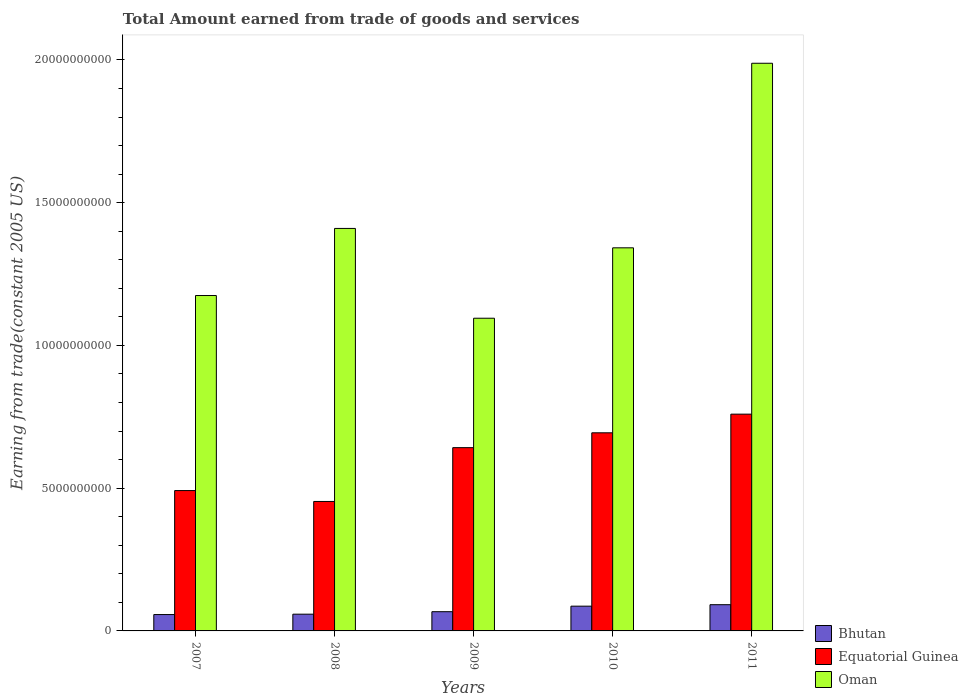Are the number of bars per tick equal to the number of legend labels?
Your answer should be very brief. Yes. How many bars are there on the 2nd tick from the right?
Offer a very short reply. 3. What is the label of the 1st group of bars from the left?
Your answer should be very brief. 2007. In how many cases, is the number of bars for a given year not equal to the number of legend labels?
Make the answer very short. 0. What is the total amount earned by trading goods and services in Bhutan in 2008?
Ensure brevity in your answer.  5.86e+08. Across all years, what is the maximum total amount earned by trading goods and services in Bhutan?
Offer a terse response. 9.19e+08. Across all years, what is the minimum total amount earned by trading goods and services in Bhutan?
Provide a succinct answer. 5.73e+08. In which year was the total amount earned by trading goods and services in Oman maximum?
Offer a terse response. 2011. What is the total total amount earned by trading goods and services in Equatorial Guinea in the graph?
Make the answer very short. 3.04e+1. What is the difference between the total amount earned by trading goods and services in Equatorial Guinea in 2009 and that in 2011?
Offer a terse response. -1.17e+09. What is the difference between the total amount earned by trading goods and services in Equatorial Guinea in 2008 and the total amount earned by trading goods and services in Bhutan in 2009?
Keep it short and to the point. 3.86e+09. What is the average total amount earned by trading goods and services in Oman per year?
Offer a terse response. 1.40e+1. In the year 2011, what is the difference between the total amount earned by trading goods and services in Bhutan and total amount earned by trading goods and services in Oman?
Your response must be concise. -1.90e+1. What is the ratio of the total amount earned by trading goods and services in Bhutan in 2007 to that in 2008?
Give a very brief answer. 0.98. Is the total amount earned by trading goods and services in Oman in 2007 less than that in 2009?
Your answer should be compact. No. Is the difference between the total amount earned by trading goods and services in Bhutan in 2008 and 2010 greater than the difference between the total amount earned by trading goods and services in Oman in 2008 and 2010?
Offer a terse response. No. What is the difference between the highest and the second highest total amount earned by trading goods and services in Equatorial Guinea?
Provide a short and direct response. 6.54e+08. What is the difference between the highest and the lowest total amount earned by trading goods and services in Oman?
Your response must be concise. 8.93e+09. What does the 1st bar from the left in 2008 represents?
Give a very brief answer. Bhutan. What does the 3rd bar from the right in 2010 represents?
Offer a terse response. Bhutan. Is it the case that in every year, the sum of the total amount earned by trading goods and services in Bhutan and total amount earned by trading goods and services in Equatorial Guinea is greater than the total amount earned by trading goods and services in Oman?
Provide a succinct answer. No. What is the difference between two consecutive major ticks on the Y-axis?
Your answer should be compact. 5.00e+09. Are the values on the major ticks of Y-axis written in scientific E-notation?
Offer a very short reply. No. Does the graph contain grids?
Make the answer very short. No. What is the title of the graph?
Ensure brevity in your answer.  Total Amount earned from trade of goods and services. What is the label or title of the X-axis?
Offer a terse response. Years. What is the label or title of the Y-axis?
Offer a very short reply. Earning from trade(constant 2005 US). What is the Earning from trade(constant 2005 US) of Bhutan in 2007?
Keep it short and to the point. 5.73e+08. What is the Earning from trade(constant 2005 US) of Equatorial Guinea in 2007?
Ensure brevity in your answer.  4.92e+09. What is the Earning from trade(constant 2005 US) of Oman in 2007?
Make the answer very short. 1.17e+1. What is the Earning from trade(constant 2005 US) of Bhutan in 2008?
Give a very brief answer. 5.86e+08. What is the Earning from trade(constant 2005 US) in Equatorial Guinea in 2008?
Offer a terse response. 4.53e+09. What is the Earning from trade(constant 2005 US) of Oman in 2008?
Make the answer very short. 1.41e+1. What is the Earning from trade(constant 2005 US) in Bhutan in 2009?
Ensure brevity in your answer.  6.73e+08. What is the Earning from trade(constant 2005 US) of Equatorial Guinea in 2009?
Provide a succinct answer. 6.42e+09. What is the Earning from trade(constant 2005 US) in Oman in 2009?
Keep it short and to the point. 1.10e+1. What is the Earning from trade(constant 2005 US) in Bhutan in 2010?
Provide a short and direct response. 8.67e+08. What is the Earning from trade(constant 2005 US) of Equatorial Guinea in 2010?
Provide a short and direct response. 6.94e+09. What is the Earning from trade(constant 2005 US) of Oman in 2010?
Give a very brief answer. 1.34e+1. What is the Earning from trade(constant 2005 US) in Bhutan in 2011?
Your response must be concise. 9.19e+08. What is the Earning from trade(constant 2005 US) in Equatorial Guinea in 2011?
Your response must be concise. 7.59e+09. What is the Earning from trade(constant 2005 US) in Oman in 2011?
Your answer should be very brief. 1.99e+1. Across all years, what is the maximum Earning from trade(constant 2005 US) of Bhutan?
Provide a short and direct response. 9.19e+08. Across all years, what is the maximum Earning from trade(constant 2005 US) in Equatorial Guinea?
Your response must be concise. 7.59e+09. Across all years, what is the maximum Earning from trade(constant 2005 US) in Oman?
Give a very brief answer. 1.99e+1. Across all years, what is the minimum Earning from trade(constant 2005 US) of Bhutan?
Give a very brief answer. 5.73e+08. Across all years, what is the minimum Earning from trade(constant 2005 US) in Equatorial Guinea?
Provide a short and direct response. 4.53e+09. Across all years, what is the minimum Earning from trade(constant 2005 US) of Oman?
Provide a succinct answer. 1.10e+1. What is the total Earning from trade(constant 2005 US) in Bhutan in the graph?
Give a very brief answer. 3.62e+09. What is the total Earning from trade(constant 2005 US) in Equatorial Guinea in the graph?
Offer a terse response. 3.04e+1. What is the total Earning from trade(constant 2005 US) in Oman in the graph?
Your answer should be compact. 7.01e+1. What is the difference between the Earning from trade(constant 2005 US) in Bhutan in 2007 and that in 2008?
Ensure brevity in your answer.  -1.31e+07. What is the difference between the Earning from trade(constant 2005 US) in Equatorial Guinea in 2007 and that in 2008?
Make the answer very short. 3.81e+08. What is the difference between the Earning from trade(constant 2005 US) of Oman in 2007 and that in 2008?
Make the answer very short. -2.35e+09. What is the difference between the Earning from trade(constant 2005 US) in Bhutan in 2007 and that in 2009?
Your answer should be compact. -1.00e+08. What is the difference between the Earning from trade(constant 2005 US) of Equatorial Guinea in 2007 and that in 2009?
Provide a short and direct response. -1.50e+09. What is the difference between the Earning from trade(constant 2005 US) in Oman in 2007 and that in 2009?
Offer a very short reply. 7.95e+08. What is the difference between the Earning from trade(constant 2005 US) in Bhutan in 2007 and that in 2010?
Provide a succinct answer. -2.94e+08. What is the difference between the Earning from trade(constant 2005 US) of Equatorial Guinea in 2007 and that in 2010?
Your answer should be compact. -2.02e+09. What is the difference between the Earning from trade(constant 2005 US) of Oman in 2007 and that in 2010?
Make the answer very short. -1.67e+09. What is the difference between the Earning from trade(constant 2005 US) of Bhutan in 2007 and that in 2011?
Keep it short and to the point. -3.46e+08. What is the difference between the Earning from trade(constant 2005 US) in Equatorial Guinea in 2007 and that in 2011?
Provide a short and direct response. -2.68e+09. What is the difference between the Earning from trade(constant 2005 US) in Oman in 2007 and that in 2011?
Make the answer very short. -8.14e+09. What is the difference between the Earning from trade(constant 2005 US) of Bhutan in 2008 and that in 2009?
Provide a short and direct response. -8.73e+07. What is the difference between the Earning from trade(constant 2005 US) of Equatorial Guinea in 2008 and that in 2009?
Your answer should be very brief. -1.88e+09. What is the difference between the Earning from trade(constant 2005 US) in Oman in 2008 and that in 2009?
Your answer should be very brief. 3.15e+09. What is the difference between the Earning from trade(constant 2005 US) in Bhutan in 2008 and that in 2010?
Give a very brief answer. -2.81e+08. What is the difference between the Earning from trade(constant 2005 US) in Equatorial Guinea in 2008 and that in 2010?
Keep it short and to the point. -2.40e+09. What is the difference between the Earning from trade(constant 2005 US) of Oman in 2008 and that in 2010?
Your answer should be compact. 6.79e+08. What is the difference between the Earning from trade(constant 2005 US) in Bhutan in 2008 and that in 2011?
Offer a terse response. -3.33e+08. What is the difference between the Earning from trade(constant 2005 US) of Equatorial Guinea in 2008 and that in 2011?
Make the answer very short. -3.06e+09. What is the difference between the Earning from trade(constant 2005 US) of Oman in 2008 and that in 2011?
Your response must be concise. -5.79e+09. What is the difference between the Earning from trade(constant 2005 US) of Bhutan in 2009 and that in 2010?
Your answer should be compact. -1.94e+08. What is the difference between the Earning from trade(constant 2005 US) in Equatorial Guinea in 2009 and that in 2010?
Offer a very short reply. -5.20e+08. What is the difference between the Earning from trade(constant 2005 US) in Oman in 2009 and that in 2010?
Give a very brief answer. -2.47e+09. What is the difference between the Earning from trade(constant 2005 US) in Bhutan in 2009 and that in 2011?
Offer a terse response. -2.45e+08. What is the difference between the Earning from trade(constant 2005 US) in Equatorial Guinea in 2009 and that in 2011?
Offer a very short reply. -1.17e+09. What is the difference between the Earning from trade(constant 2005 US) of Oman in 2009 and that in 2011?
Ensure brevity in your answer.  -8.93e+09. What is the difference between the Earning from trade(constant 2005 US) in Bhutan in 2010 and that in 2011?
Your response must be concise. -5.17e+07. What is the difference between the Earning from trade(constant 2005 US) of Equatorial Guinea in 2010 and that in 2011?
Provide a short and direct response. -6.54e+08. What is the difference between the Earning from trade(constant 2005 US) of Oman in 2010 and that in 2011?
Make the answer very short. -6.46e+09. What is the difference between the Earning from trade(constant 2005 US) in Bhutan in 2007 and the Earning from trade(constant 2005 US) in Equatorial Guinea in 2008?
Offer a terse response. -3.96e+09. What is the difference between the Earning from trade(constant 2005 US) in Bhutan in 2007 and the Earning from trade(constant 2005 US) in Oman in 2008?
Your answer should be compact. -1.35e+1. What is the difference between the Earning from trade(constant 2005 US) of Equatorial Guinea in 2007 and the Earning from trade(constant 2005 US) of Oman in 2008?
Your response must be concise. -9.18e+09. What is the difference between the Earning from trade(constant 2005 US) in Bhutan in 2007 and the Earning from trade(constant 2005 US) in Equatorial Guinea in 2009?
Ensure brevity in your answer.  -5.85e+09. What is the difference between the Earning from trade(constant 2005 US) in Bhutan in 2007 and the Earning from trade(constant 2005 US) in Oman in 2009?
Ensure brevity in your answer.  -1.04e+1. What is the difference between the Earning from trade(constant 2005 US) of Equatorial Guinea in 2007 and the Earning from trade(constant 2005 US) of Oman in 2009?
Keep it short and to the point. -6.04e+09. What is the difference between the Earning from trade(constant 2005 US) in Bhutan in 2007 and the Earning from trade(constant 2005 US) in Equatorial Guinea in 2010?
Offer a terse response. -6.37e+09. What is the difference between the Earning from trade(constant 2005 US) in Bhutan in 2007 and the Earning from trade(constant 2005 US) in Oman in 2010?
Provide a succinct answer. -1.28e+1. What is the difference between the Earning from trade(constant 2005 US) of Equatorial Guinea in 2007 and the Earning from trade(constant 2005 US) of Oman in 2010?
Ensure brevity in your answer.  -8.50e+09. What is the difference between the Earning from trade(constant 2005 US) in Bhutan in 2007 and the Earning from trade(constant 2005 US) in Equatorial Guinea in 2011?
Your answer should be very brief. -7.02e+09. What is the difference between the Earning from trade(constant 2005 US) in Bhutan in 2007 and the Earning from trade(constant 2005 US) in Oman in 2011?
Your response must be concise. -1.93e+1. What is the difference between the Earning from trade(constant 2005 US) of Equatorial Guinea in 2007 and the Earning from trade(constant 2005 US) of Oman in 2011?
Offer a terse response. -1.50e+1. What is the difference between the Earning from trade(constant 2005 US) of Bhutan in 2008 and the Earning from trade(constant 2005 US) of Equatorial Guinea in 2009?
Provide a succinct answer. -5.83e+09. What is the difference between the Earning from trade(constant 2005 US) in Bhutan in 2008 and the Earning from trade(constant 2005 US) in Oman in 2009?
Provide a short and direct response. -1.04e+1. What is the difference between the Earning from trade(constant 2005 US) of Equatorial Guinea in 2008 and the Earning from trade(constant 2005 US) of Oman in 2009?
Offer a terse response. -6.42e+09. What is the difference between the Earning from trade(constant 2005 US) in Bhutan in 2008 and the Earning from trade(constant 2005 US) in Equatorial Guinea in 2010?
Provide a succinct answer. -6.35e+09. What is the difference between the Earning from trade(constant 2005 US) in Bhutan in 2008 and the Earning from trade(constant 2005 US) in Oman in 2010?
Your response must be concise. -1.28e+1. What is the difference between the Earning from trade(constant 2005 US) in Equatorial Guinea in 2008 and the Earning from trade(constant 2005 US) in Oman in 2010?
Provide a succinct answer. -8.88e+09. What is the difference between the Earning from trade(constant 2005 US) in Bhutan in 2008 and the Earning from trade(constant 2005 US) in Equatorial Guinea in 2011?
Your answer should be compact. -7.01e+09. What is the difference between the Earning from trade(constant 2005 US) in Bhutan in 2008 and the Earning from trade(constant 2005 US) in Oman in 2011?
Give a very brief answer. -1.93e+1. What is the difference between the Earning from trade(constant 2005 US) of Equatorial Guinea in 2008 and the Earning from trade(constant 2005 US) of Oman in 2011?
Offer a very short reply. -1.53e+1. What is the difference between the Earning from trade(constant 2005 US) of Bhutan in 2009 and the Earning from trade(constant 2005 US) of Equatorial Guinea in 2010?
Keep it short and to the point. -6.27e+09. What is the difference between the Earning from trade(constant 2005 US) of Bhutan in 2009 and the Earning from trade(constant 2005 US) of Oman in 2010?
Make the answer very short. -1.27e+1. What is the difference between the Earning from trade(constant 2005 US) of Equatorial Guinea in 2009 and the Earning from trade(constant 2005 US) of Oman in 2010?
Ensure brevity in your answer.  -7.00e+09. What is the difference between the Earning from trade(constant 2005 US) of Bhutan in 2009 and the Earning from trade(constant 2005 US) of Equatorial Guinea in 2011?
Provide a succinct answer. -6.92e+09. What is the difference between the Earning from trade(constant 2005 US) in Bhutan in 2009 and the Earning from trade(constant 2005 US) in Oman in 2011?
Provide a succinct answer. -1.92e+1. What is the difference between the Earning from trade(constant 2005 US) of Equatorial Guinea in 2009 and the Earning from trade(constant 2005 US) of Oman in 2011?
Provide a short and direct response. -1.35e+1. What is the difference between the Earning from trade(constant 2005 US) of Bhutan in 2010 and the Earning from trade(constant 2005 US) of Equatorial Guinea in 2011?
Offer a very short reply. -6.73e+09. What is the difference between the Earning from trade(constant 2005 US) of Bhutan in 2010 and the Earning from trade(constant 2005 US) of Oman in 2011?
Your answer should be compact. -1.90e+1. What is the difference between the Earning from trade(constant 2005 US) of Equatorial Guinea in 2010 and the Earning from trade(constant 2005 US) of Oman in 2011?
Your answer should be very brief. -1.29e+1. What is the average Earning from trade(constant 2005 US) in Bhutan per year?
Make the answer very short. 7.24e+08. What is the average Earning from trade(constant 2005 US) in Equatorial Guinea per year?
Make the answer very short. 6.08e+09. What is the average Earning from trade(constant 2005 US) in Oman per year?
Provide a succinct answer. 1.40e+1. In the year 2007, what is the difference between the Earning from trade(constant 2005 US) of Bhutan and Earning from trade(constant 2005 US) of Equatorial Guinea?
Offer a very short reply. -4.34e+09. In the year 2007, what is the difference between the Earning from trade(constant 2005 US) of Bhutan and Earning from trade(constant 2005 US) of Oman?
Provide a succinct answer. -1.12e+1. In the year 2007, what is the difference between the Earning from trade(constant 2005 US) in Equatorial Guinea and Earning from trade(constant 2005 US) in Oman?
Offer a very short reply. -6.83e+09. In the year 2008, what is the difference between the Earning from trade(constant 2005 US) in Bhutan and Earning from trade(constant 2005 US) in Equatorial Guinea?
Keep it short and to the point. -3.95e+09. In the year 2008, what is the difference between the Earning from trade(constant 2005 US) of Bhutan and Earning from trade(constant 2005 US) of Oman?
Your answer should be very brief. -1.35e+1. In the year 2008, what is the difference between the Earning from trade(constant 2005 US) of Equatorial Guinea and Earning from trade(constant 2005 US) of Oman?
Provide a succinct answer. -9.56e+09. In the year 2009, what is the difference between the Earning from trade(constant 2005 US) of Bhutan and Earning from trade(constant 2005 US) of Equatorial Guinea?
Make the answer very short. -5.75e+09. In the year 2009, what is the difference between the Earning from trade(constant 2005 US) of Bhutan and Earning from trade(constant 2005 US) of Oman?
Provide a short and direct response. -1.03e+1. In the year 2009, what is the difference between the Earning from trade(constant 2005 US) of Equatorial Guinea and Earning from trade(constant 2005 US) of Oman?
Your answer should be compact. -4.53e+09. In the year 2010, what is the difference between the Earning from trade(constant 2005 US) of Bhutan and Earning from trade(constant 2005 US) of Equatorial Guinea?
Keep it short and to the point. -6.07e+09. In the year 2010, what is the difference between the Earning from trade(constant 2005 US) in Bhutan and Earning from trade(constant 2005 US) in Oman?
Offer a terse response. -1.26e+1. In the year 2010, what is the difference between the Earning from trade(constant 2005 US) in Equatorial Guinea and Earning from trade(constant 2005 US) in Oman?
Offer a very short reply. -6.48e+09. In the year 2011, what is the difference between the Earning from trade(constant 2005 US) in Bhutan and Earning from trade(constant 2005 US) in Equatorial Guinea?
Ensure brevity in your answer.  -6.67e+09. In the year 2011, what is the difference between the Earning from trade(constant 2005 US) of Bhutan and Earning from trade(constant 2005 US) of Oman?
Keep it short and to the point. -1.90e+1. In the year 2011, what is the difference between the Earning from trade(constant 2005 US) in Equatorial Guinea and Earning from trade(constant 2005 US) in Oman?
Give a very brief answer. -1.23e+1. What is the ratio of the Earning from trade(constant 2005 US) in Bhutan in 2007 to that in 2008?
Your answer should be compact. 0.98. What is the ratio of the Earning from trade(constant 2005 US) in Equatorial Guinea in 2007 to that in 2008?
Provide a succinct answer. 1.08. What is the ratio of the Earning from trade(constant 2005 US) of Oman in 2007 to that in 2008?
Provide a short and direct response. 0.83. What is the ratio of the Earning from trade(constant 2005 US) of Bhutan in 2007 to that in 2009?
Your answer should be compact. 0.85. What is the ratio of the Earning from trade(constant 2005 US) of Equatorial Guinea in 2007 to that in 2009?
Offer a very short reply. 0.77. What is the ratio of the Earning from trade(constant 2005 US) of Oman in 2007 to that in 2009?
Give a very brief answer. 1.07. What is the ratio of the Earning from trade(constant 2005 US) in Bhutan in 2007 to that in 2010?
Make the answer very short. 0.66. What is the ratio of the Earning from trade(constant 2005 US) of Equatorial Guinea in 2007 to that in 2010?
Provide a succinct answer. 0.71. What is the ratio of the Earning from trade(constant 2005 US) in Oman in 2007 to that in 2010?
Offer a terse response. 0.88. What is the ratio of the Earning from trade(constant 2005 US) in Bhutan in 2007 to that in 2011?
Ensure brevity in your answer.  0.62. What is the ratio of the Earning from trade(constant 2005 US) of Equatorial Guinea in 2007 to that in 2011?
Make the answer very short. 0.65. What is the ratio of the Earning from trade(constant 2005 US) of Oman in 2007 to that in 2011?
Your answer should be very brief. 0.59. What is the ratio of the Earning from trade(constant 2005 US) in Bhutan in 2008 to that in 2009?
Your answer should be compact. 0.87. What is the ratio of the Earning from trade(constant 2005 US) in Equatorial Guinea in 2008 to that in 2009?
Ensure brevity in your answer.  0.71. What is the ratio of the Earning from trade(constant 2005 US) of Oman in 2008 to that in 2009?
Provide a succinct answer. 1.29. What is the ratio of the Earning from trade(constant 2005 US) in Bhutan in 2008 to that in 2010?
Ensure brevity in your answer.  0.68. What is the ratio of the Earning from trade(constant 2005 US) of Equatorial Guinea in 2008 to that in 2010?
Give a very brief answer. 0.65. What is the ratio of the Earning from trade(constant 2005 US) in Oman in 2008 to that in 2010?
Your response must be concise. 1.05. What is the ratio of the Earning from trade(constant 2005 US) of Bhutan in 2008 to that in 2011?
Keep it short and to the point. 0.64. What is the ratio of the Earning from trade(constant 2005 US) of Equatorial Guinea in 2008 to that in 2011?
Offer a terse response. 0.6. What is the ratio of the Earning from trade(constant 2005 US) in Oman in 2008 to that in 2011?
Your answer should be very brief. 0.71. What is the ratio of the Earning from trade(constant 2005 US) in Bhutan in 2009 to that in 2010?
Provide a succinct answer. 0.78. What is the ratio of the Earning from trade(constant 2005 US) in Equatorial Guinea in 2009 to that in 2010?
Offer a very short reply. 0.93. What is the ratio of the Earning from trade(constant 2005 US) of Oman in 2009 to that in 2010?
Offer a very short reply. 0.82. What is the ratio of the Earning from trade(constant 2005 US) in Bhutan in 2009 to that in 2011?
Ensure brevity in your answer.  0.73. What is the ratio of the Earning from trade(constant 2005 US) of Equatorial Guinea in 2009 to that in 2011?
Your answer should be compact. 0.85. What is the ratio of the Earning from trade(constant 2005 US) of Oman in 2009 to that in 2011?
Provide a short and direct response. 0.55. What is the ratio of the Earning from trade(constant 2005 US) in Bhutan in 2010 to that in 2011?
Ensure brevity in your answer.  0.94. What is the ratio of the Earning from trade(constant 2005 US) of Equatorial Guinea in 2010 to that in 2011?
Your answer should be compact. 0.91. What is the ratio of the Earning from trade(constant 2005 US) in Oman in 2010 to that in 2011?
Provide a short and direct response. 0.67. What is the difference between the highest and the second highest Earning from trade(constant 2005 US) in Bhutan?
Offer a terse response. 5.17e+07. What is the difference between the highest and the second highest Earning from trade(constant 2005 US) of Equatorial Guinea?
Ensure brevity in your answer.  6.54e+08. What is the difference between the highest and the second highest Earning from trade(constant 2005 US) in Oman?
Keep it short and to the point. 5.79e+09. What is the difference between the highest and the lowest Earning from trade(constant 2005 US) in Bhutan?
Your answer should be compact. 3.46e+08. What is the difference between the highest and the lowest Earning from trade(constant 2005 US) in Equatorial Guinea?
Keep it short and to the point. 3.06e+09. What is the difference between the highest and the lowest Earning from trade(constant 2005 US) of Oman?
Offer a terse response. 8.93e+09. 